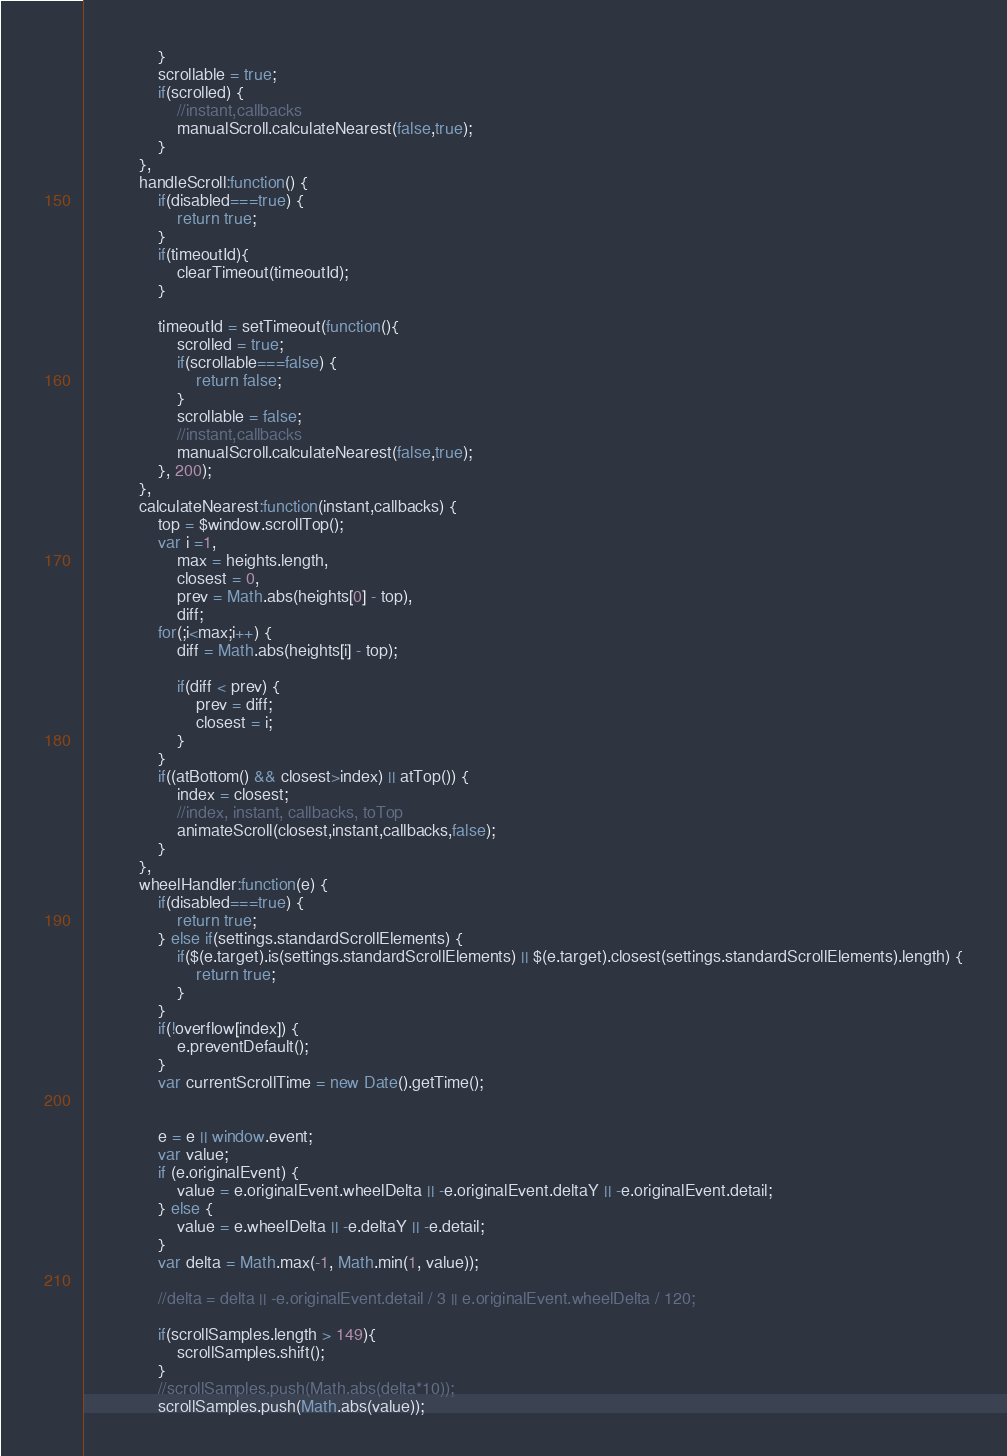<code> <loc_0><loc_0><loc_500><loc_500><_JavaScript_>                }
                scrollable = true;
                if(scrolled) {
                    //instant,callbacks
                    manualScroll.calculateNearest(false,true);
                }
            },
            handleScroll:function() {
                if(disabled===true) {
                    return true;
                }
                if(timeoutId){
                    clearTimeout(timeoutId);
                }

                timeoutId = setTimeout(function(){
                    scrolled = true;
                    if(scrollable===false) {
                        return false;
                    }
                    scrollable = false;
                    //instant,callbacks
                    manualScroll.calculateNearest(false,true);
                }, 200);
            },
            calculateNearest:function(instant,callbacks) {
                top = $window.scrollTop();
                var i =1,
                    max = heights.length,
                    closest = 0,
                    prev = Math.abs(heights[0] - top),
                    diff;
                for(;i<max;i++) {
                    diff = Math.abs(heights[i] - top);

                    if(diff < prev) {
                        prev = diff;
                        closest = i;
                    }
                }
                if((atBottom() && closest>index) || atTop()) {
                    index = closest;
                    //index, instant, callbacks, toTop
                    animateScroll(closest,instant,callbacks,false);
                }
            },
            wheelHandler:function(e) {
                if(disabled===true) {
                    return true;
                } else if(settings.standardScrollElements) {
                    if($(e.target).is(settings.standardScrollElements) || $(e.target).closest(settings.standardScrollElements).length) {
                        return true;
                    }
                }
                if(!overflow[index]) {
                    e.preventDefault();
                }
                var currentScrollTime = new Date().getTime();


                e = e || window.event;
                var value;
                if (e.originalEvent) {
                    value = e.originalEvent.wheelDelta || -e.originalEvent.deltaY || -e.originalEvent.detail;
                } else {
                    value = e.wheelDelta || -e.deltaY || -e.detail;
                }
                var delta = Math.max(-1, Math.min(1, value));

                //delta = delta || -e.originalEvent.detail / 3 || e.originalEvent.wheelDelta / 120;

                if(scrollSamples.length > 149){
                    scrollSamples.shift();
                }
                //scrollSamples.push(Math.abs(delta*10));
                scrollSamples.push(Math.abs(value));
</code> 